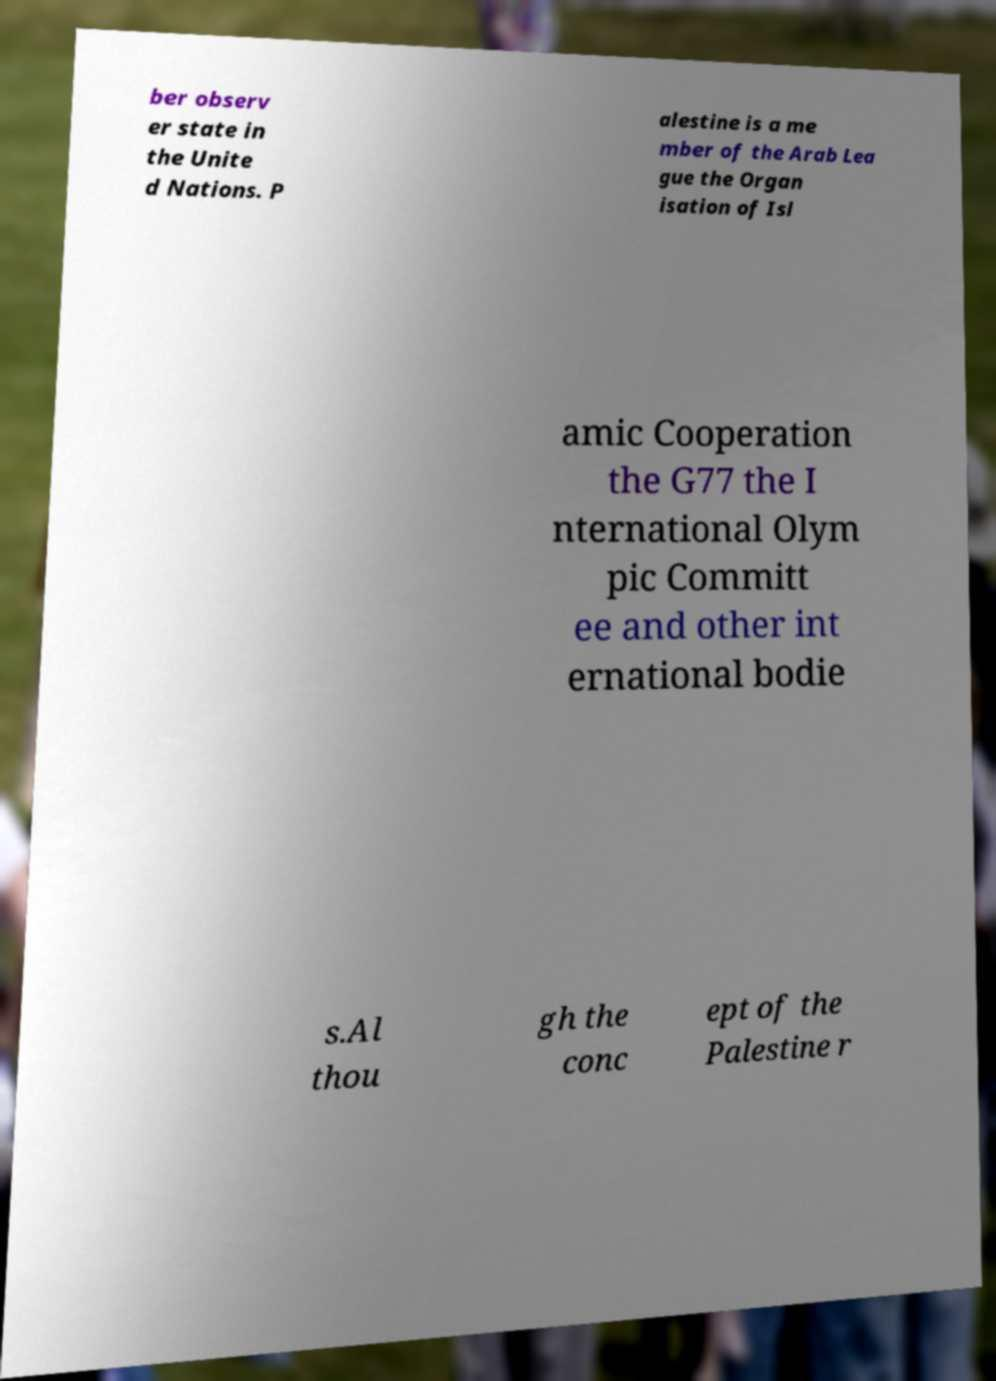Can you read and provide the text displayed in the image?This photo seems to have some interesting text. Can you extract and type it out for me? ber observ er state in the Unite d Nations. P alestine is a me mber of the Arab Lea gue the Organ isation of Isl amic Cooperation the G77 the I nternational Olym pic Committ ee and other int ernational bodie s.Al thou gh the conc ept of the Palestine r 